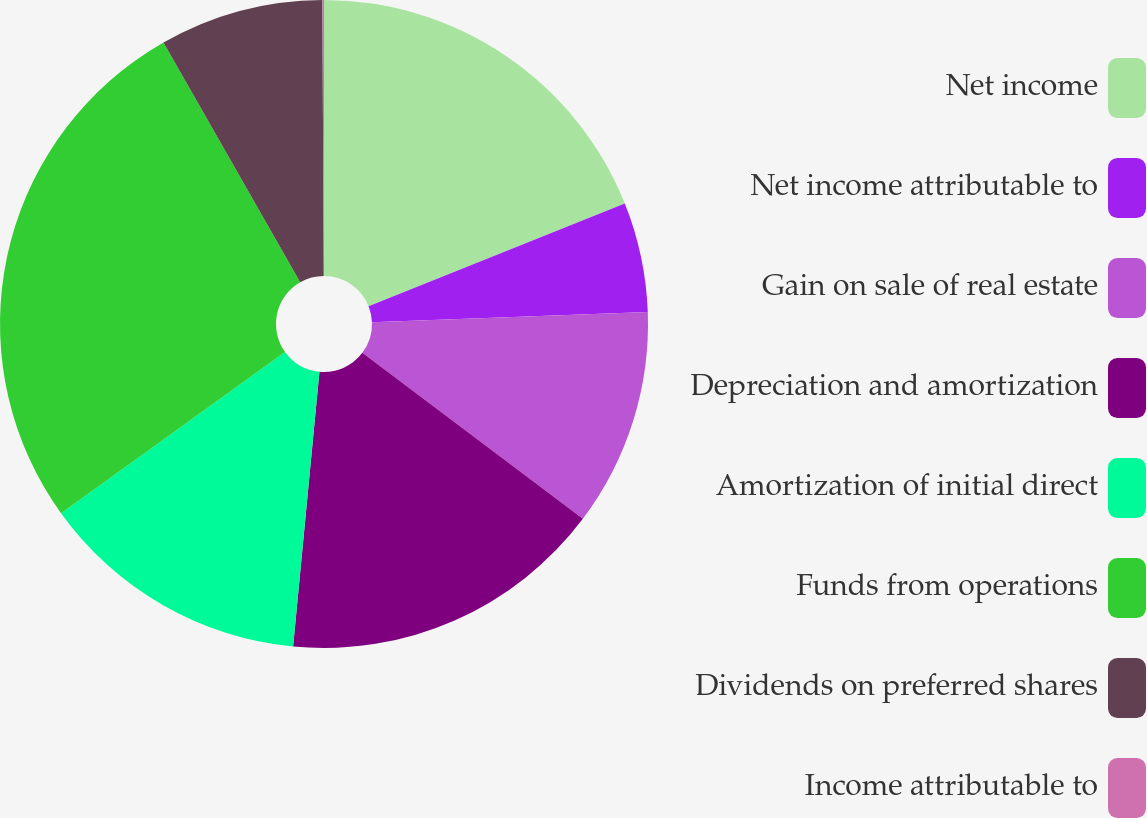Convert chart to OTSL. <chart><loc_0><loc_0><loc_500><loc_500><pie_chart><fcel>Net income<fcel>Net income attributable to<fcel>Gain on sale of real estate<fcel>Depreciation and amortization<fcel>Amortization of initial direct<fcel>Funds from operations<fcel>Dividends on preferred shares<fcel>Income attributable to<nl><fcel>18.94%<fcel>5.47%<fcel>10.86%<fcel>16.25%<fcel>13.55%<fcel>26.68%<fcel>8.17%<fcel>0.08%<nl></chart> 